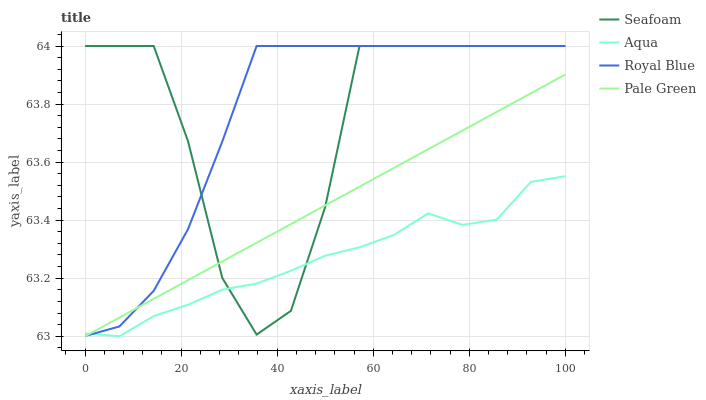Does Aqua have the minimum area under the curve?
Answer yes or no. Yes. Does Royal Blue have the maximum area under the curve?
Answer yes or no. Yes. Does Pale Green have the minimum area under the curve?
Answer yes or no. No. Does Pale Green have the maximum area under the curve?
Answer yes or no. No. Is Pale Green the smoothest?
Answer yes or no. Yes. Is Seafoam the roughest?
Answer yes or no. Yes. Is Aqua the smoothest?
Answer yes or no. No. Is Aqua the roughest?
Answer yes or no. No. Does Pale Green have the lowest value?
Answer yes or no. Yes. Does Seafoam have the lowest value?
Answer yes or no. No. Does Seafoam have the highest value?
Answer yes or no. Yes. Does Pale Green have the highest value?
Answer yes or no. No. Does Pale Green intersect Aqua?
Answer yes or no. Yes. Is Pale Green less than Aqua?
Answer yes or no. No. Is Pale Green greater than Aqua?
Answer yes or no. No. 